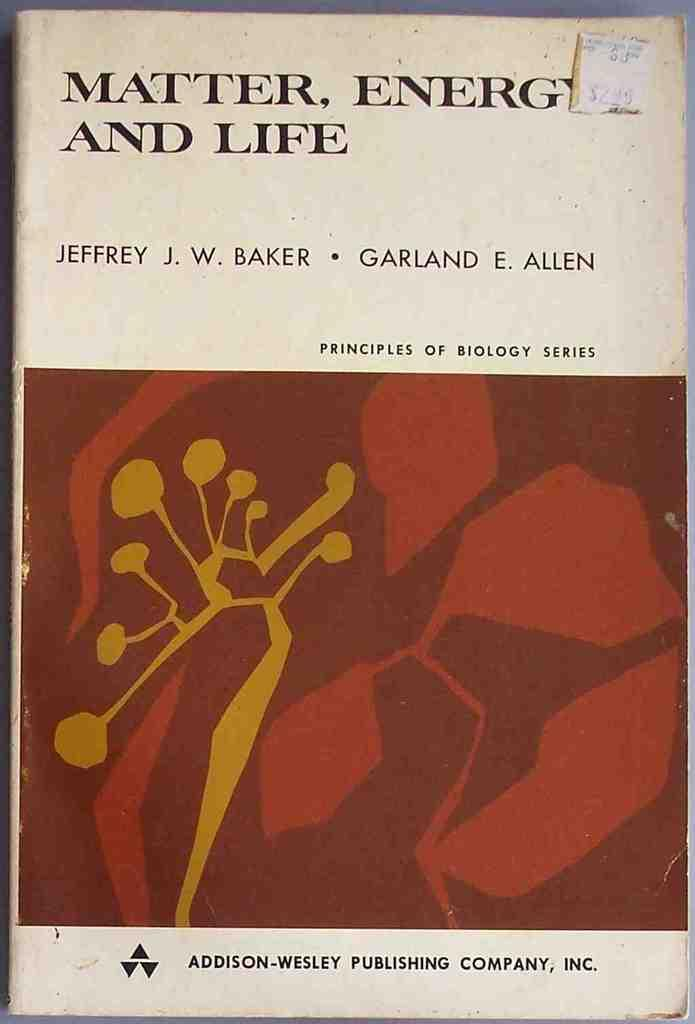<image>
Describe the image concisely. Matter, energy, and life book by Jeffrey J. W. Baker and Garland E. Allen 